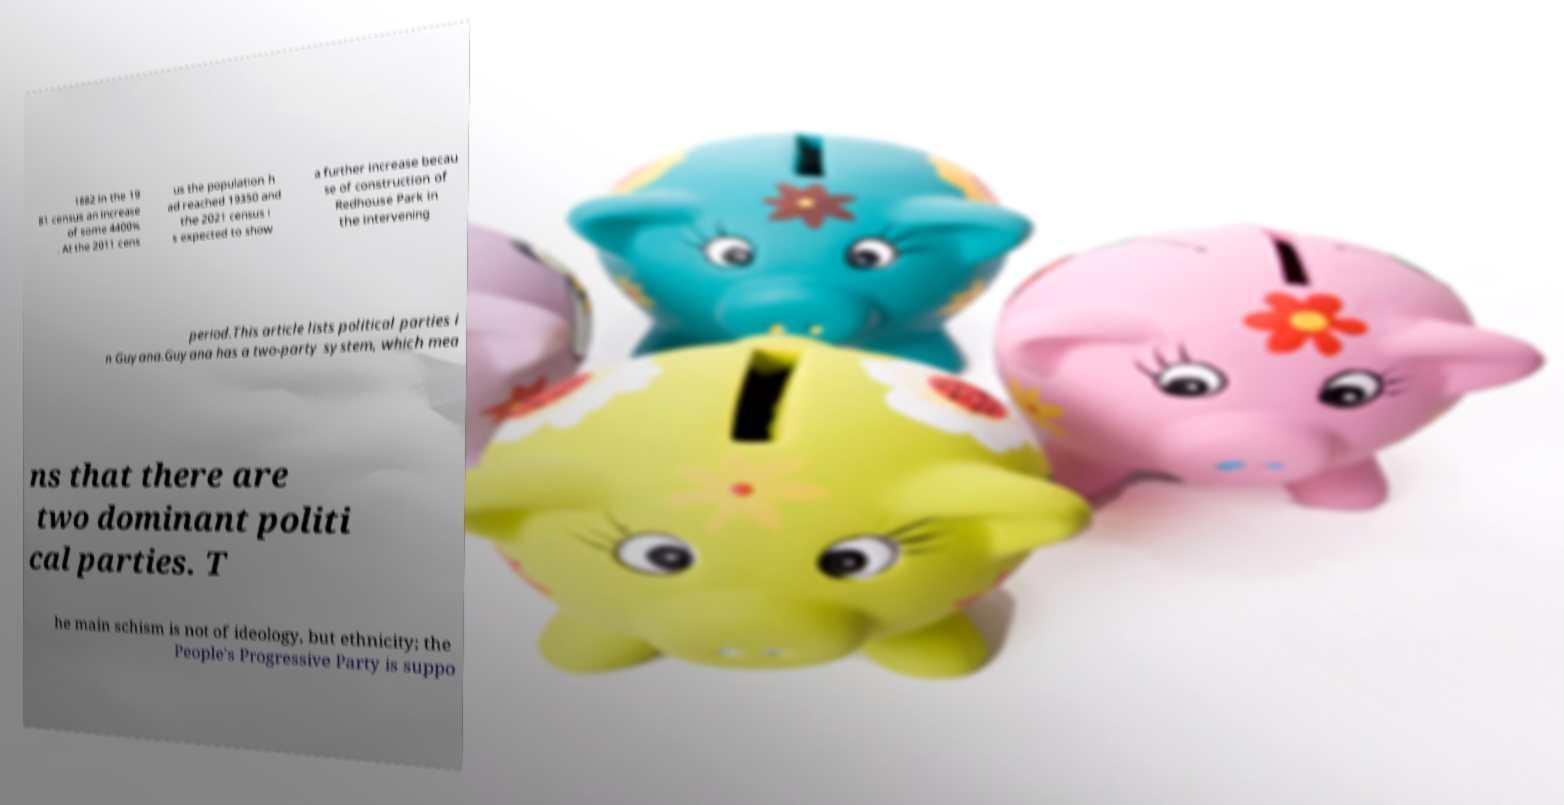Please read and relay the text visible in this image. What does it say? 1882 in the 19 81 census an increase of some 4400% . At the 2011 cens us the population h ad reached 19350 and the 2021 census i s expected to show a further increase becau se of construction of Redhouse Park in the intervening period.This article lists political parties i n Guyana.Guyana has a two-party system, which mea ns that there are two dominant politi cal parties. T he main schism is not of ideology, but ethnicity; the People's Progressive Party is suppo 